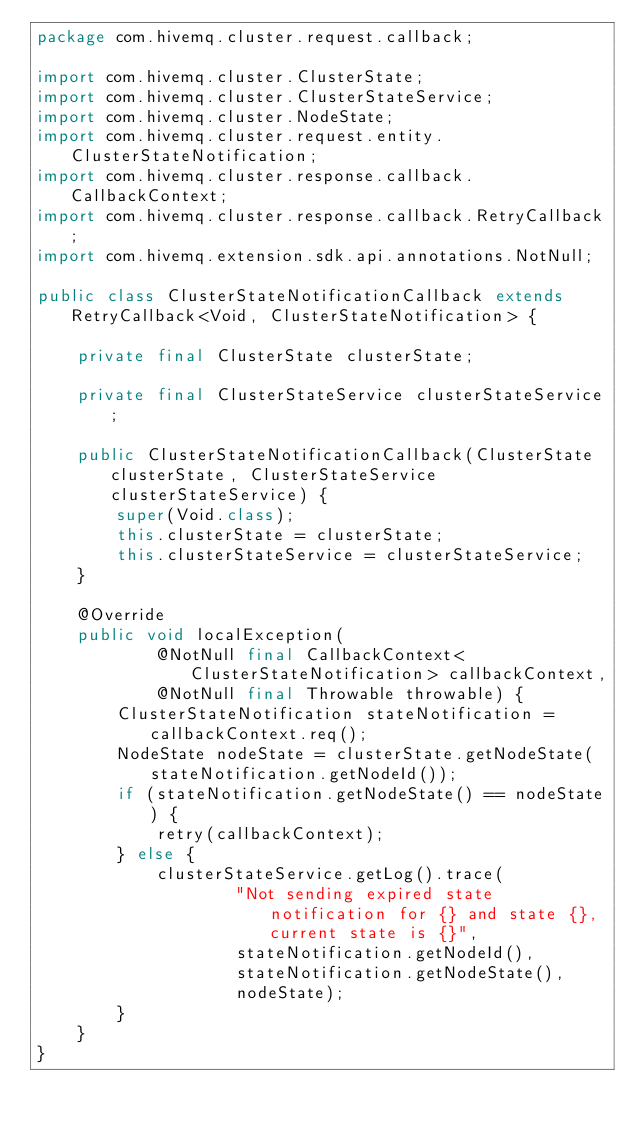<code> <loc_0><loc_0><loc_500><loc_500><_Java_>package com.hivemq.cluster.request.callback;

import com.hivemq.cluster.ClusterState;
import com.hivemq.cluster.ClusterStateService;
import com.hivemq.cluster.NodeState;
import com.hivemq.cluster.request.entity.ClusterStateNotification;
import com.hivemq.cluster.response.callback.CallbackContext;
import com.hivemq.cluster.response.callback.RetryCallback;
import com.hivemq.extension.sdk.api.annotations.NotNull;

public class ClusterStateNotificationCallback extends RetryCallback<Void, ClusterStateNotification> {

    private final ClusterState clusterState;

    private final ClusterStateService clusterStateService;

    public ClusterStateNotificationCallback(ClusterState clusterState, ClusterStateService clusterStateService) {
        super(Void.class);
        this.clusterState = clusterState;
        this.clusterStateService = clusterStateService;
    }

    @Override
    public void localException(
            @NotNull final CallbackContext<ClusterStateNotification> callbackContext,
            @NotNull final Throwable throwable) {
        ClusterStateNotification stateNotification = callbackContext.req();
        NodeState nodeState = clusterState.getNodeState(stateNotification.getNodeId());
        if (stateNotification.getNodeState() == nodeState) {
            retry(callbackContext);
        } else {
            clusterStateService.getLog().trace(
                    "Not sending expired state notification for {} and state {}, current state is {}",
                    stateNotification.getNodeId(),
                    stateNotification.getNodeState(),
                    nodeState);
        }
    }
}
</code> 